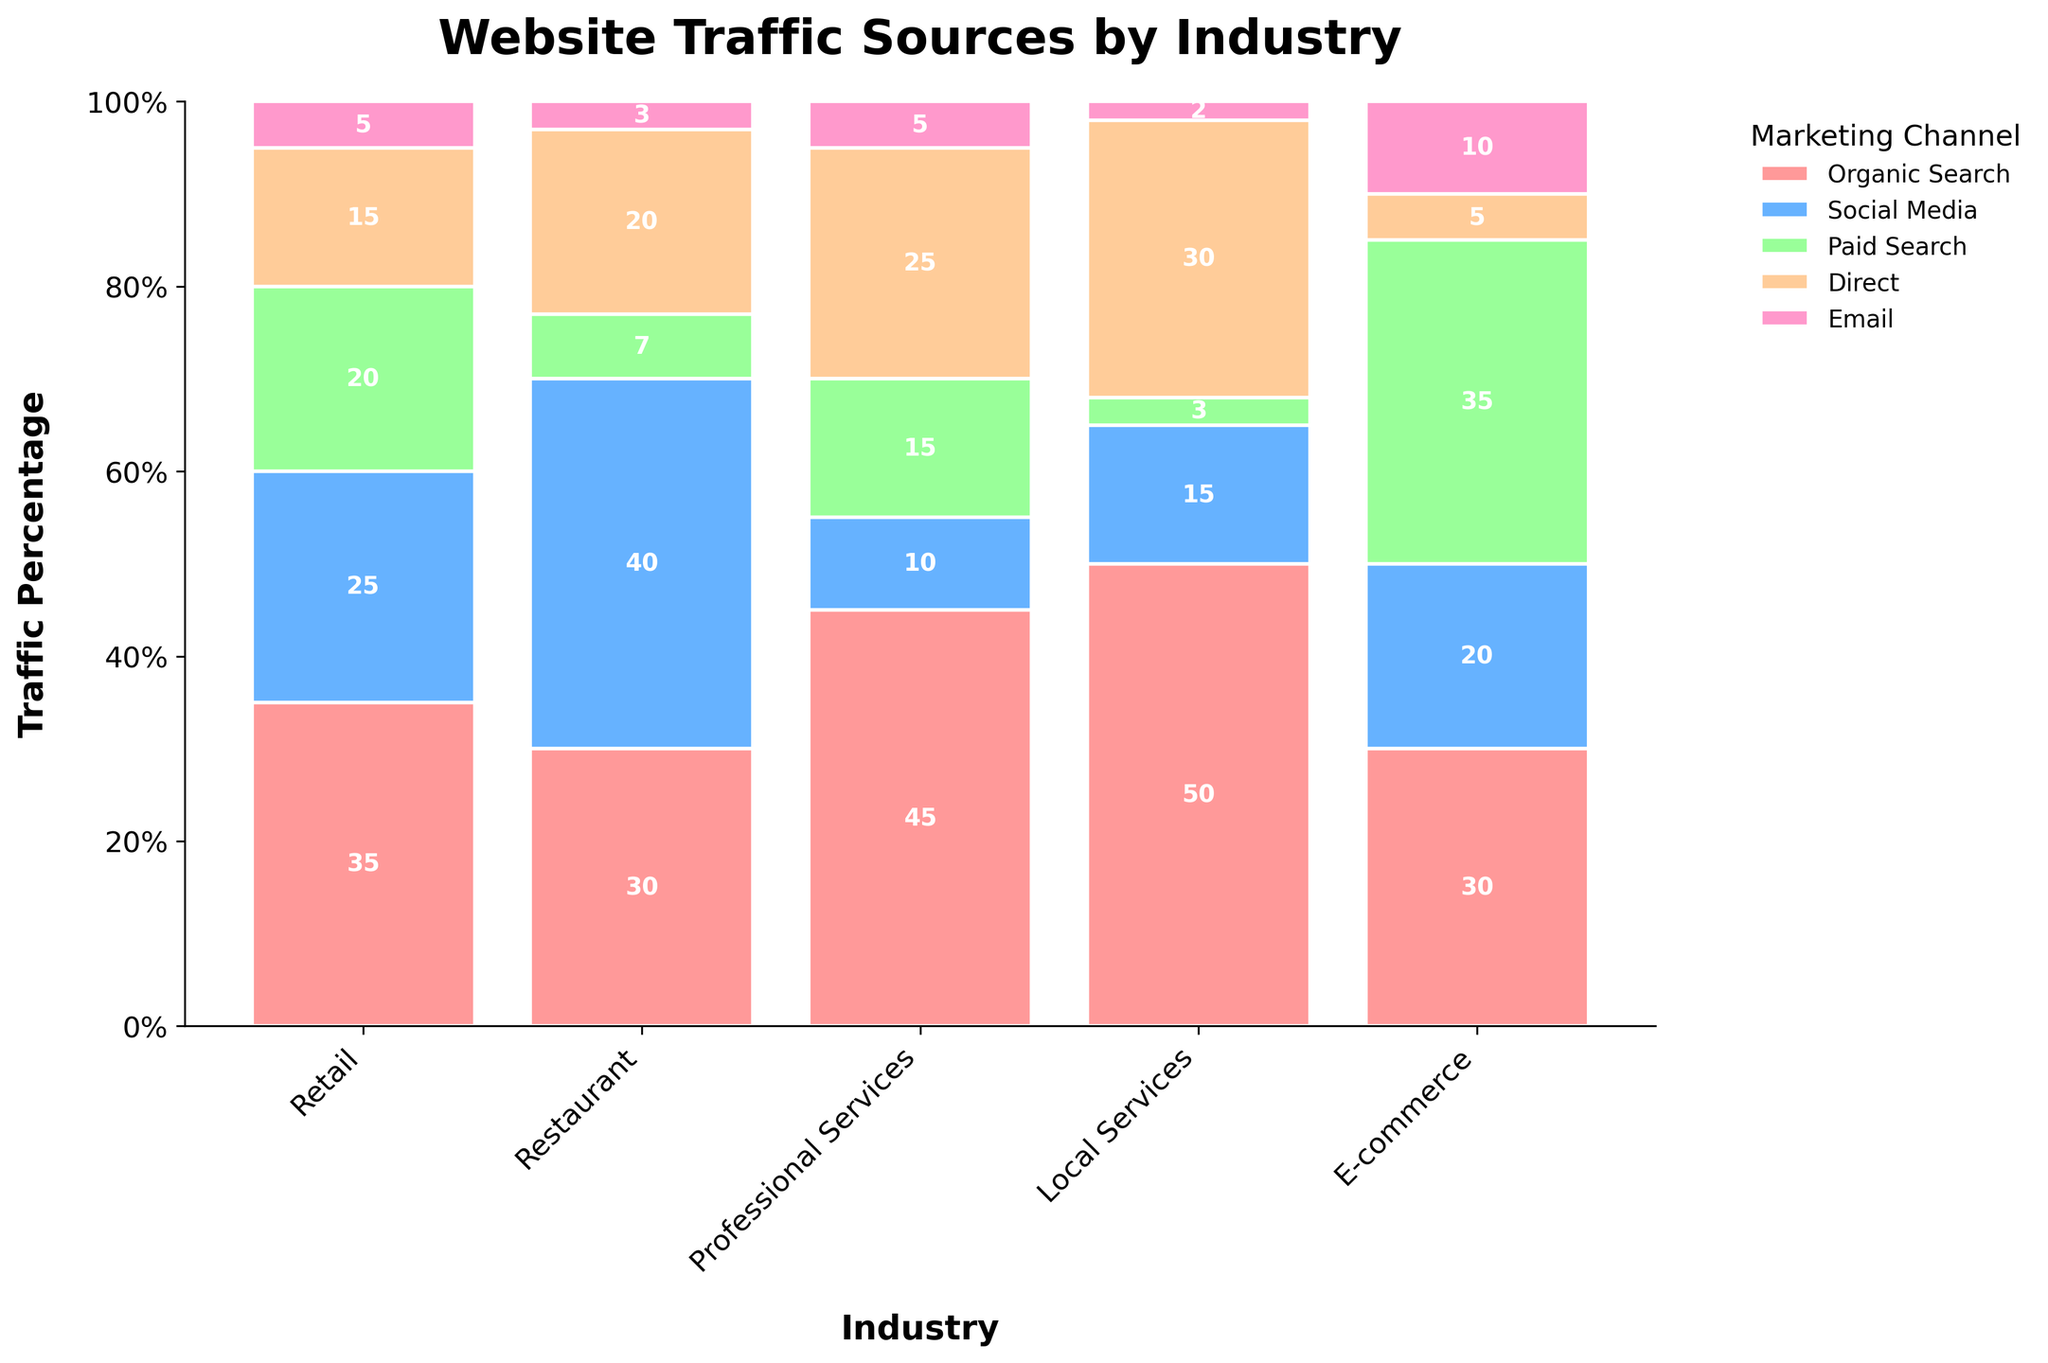What is the title of the plot? The title is placed at the top of the plot and usually describes what the plot is showing. The title of this plot, obtained from the plot code, is "Website Traffic Sources by Industry."
Answer: Website Traffic Sources by Industry Which industry has the highest percentage of traffic from Organic Search? To determine this, look at the segments of the bars labeled "Organic Search" and find the industry whose segment reaches the highest point on the y-axis. For "Local Services," Organic Search occupies up to 50%.
Answer: Local Services What percentage of traffic does Social Media contribute to the Restaurant industry? Locate the bar corresponding to "Restaurant" and focus on the segment labeled "Social Media." The y-axis value at the top of the segment represents the percentage, which is 40%.
Answer: 40% Which marketing channel contributes the smallest percentage of traffic for the Retail industry? Examine the segments within the "Retail" bar, and identify the shortest one. The "Email" segment is the smallest, contributing only 5%.
Answer: Email How does the percentage of traffic from Paid Search compare between the E-commerce and Professional Services industries? Look at the "Paid Search" segments for E-commerce and Professional Services bars. E-commerce has a Paid Search percentage of 35%, whereas Professional Services has 15%. Therefore, E-commerce has a higher percentage.
Answer: E-commerce has a higher percentage What is the total percentage of traffic from Direct and Email channels for Local Services? Identify the "Direct" and "Email" segments within the "Local Services" bar. "Direct" has 30% and "Email" has 2%. Summing these values gives 30% + 2% = 32%.
Answer: 32% In which industry does Social Media contribute a higher percentage of traffic compared to Direct? By observing the "Social Media" and "Direct" segments for each industry, we find that in the Restaurant industry, Social Media (40%) is higher than Direct (20%).
Answer: Restaurant What's the difference in Organic Search traffic between Retail and Restaurant industries? Find the "Organic Search" segments for Retail (35%) and Restaurant (30%) bars. The difference is 35% - 30% = 5%.
Answer: 5% What is the percentage distribution for the Professional Services industry? Examine the segments within the "Professional Services" bar. Organic Search is 45%, Direct is 25%, Paid Search is 15%, Social Media is 10%, and Email is 5%. Adding these percentages should sum up to 100%.
Answer: Organic Search: 45%, Direct: 25%, Paid Search: 15%, Social Media: 10%, Email: 5% Which marketing channel shows the least variation in traffic percentage across all industries? To find the least variation, assess the segment heights across all industries for each channel. "Email" appears to be consistently low, ranging between 2% to 5%.
Answer: Email 